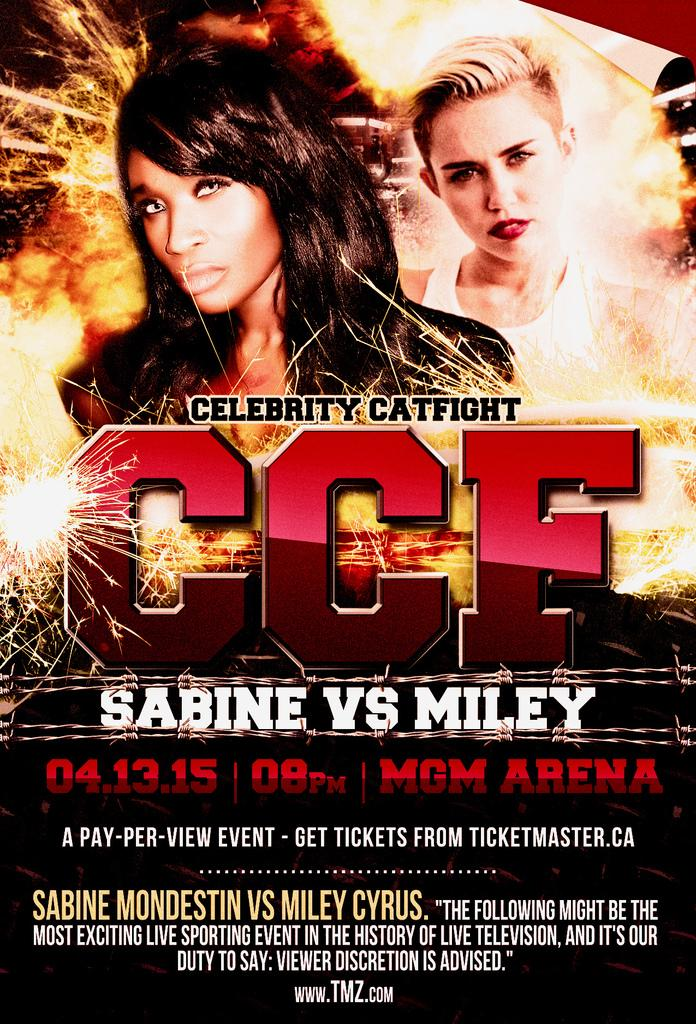<image>
Relay a brief, clear account of the picture shown. A poster for Celebrity Catfight features Sabine Vs Miley on 04.13.15 at the MGM Arena. 